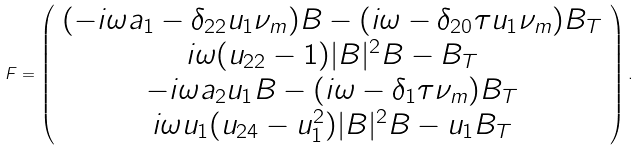<formula> <loc_0><loc_0><loc_500><loc_500>F = \left ( \begin{array} { c } ( - i \omega a _ { 1 } - \delta _ { 2 2 } u _ { 1 } \nu _ { m } ) B - ( i \omega - \delta _ { 2 0 } \tau u _ { 1 } \nu _ { m } ) B _ { T } \\ i \omega ( u _ { 2 2 } - 1 ) | B | ^ { 2 } B - B _ { T } \\ - i \omega a _ { 2 } u _ { 1 } B - ( i \omega - \delta _ { 1 } \tau \nu _ { m } ) B _ { T } \\ i \omega u _ { 1 } ( u _ { 2 4 } - u _ { 1 } ^ { 2 } ) | B | ^ { 2 } B - u _ { 1 } B _ { T } \end{array} \right ) .</formula> 